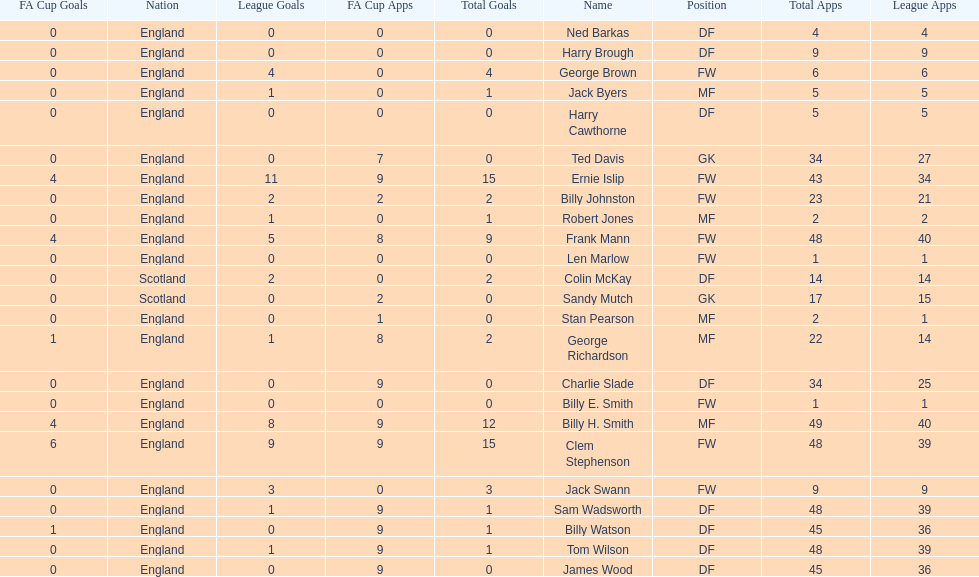What is the last name listed on this chart? James Wood. 